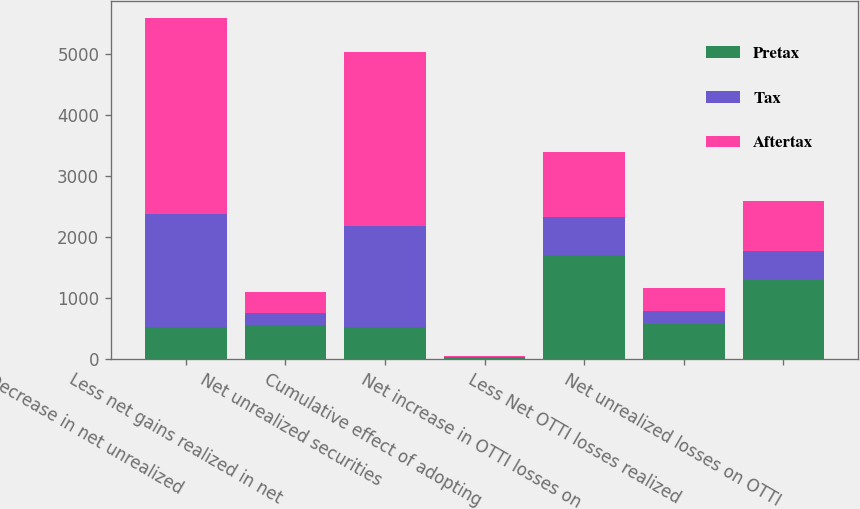<chart> <loc_0><loc_0><loc_500><loc_500><stacked_bar_chart><ecel><fcel>Decrease in net unrealized<fcel>Less net gains realized in net<fcel>Net unrealized securities<fcel>Cumulative effect of adopting<fcel>Net increase in OTTI losses on<fcel>Less Net OTTI losses realized<fcel>Net unrealized losses on OTTI<nl><fcel>Pretax<fcel>515<fcel>550<fcel>515<fcel>20<fcel>1699<fcel>577<fcel>1296<nl><fcel>Tax<fcel>1863<fcel>204<fcel>1659<fcel>7<fcel>630<fcel>214<fcel>480<nl><fcel>Aftertax<fcel>3212<fcel>346<fcel>2866<fcel>13<fcel>1069<fcel>363<fcel>816<nl></chart> 